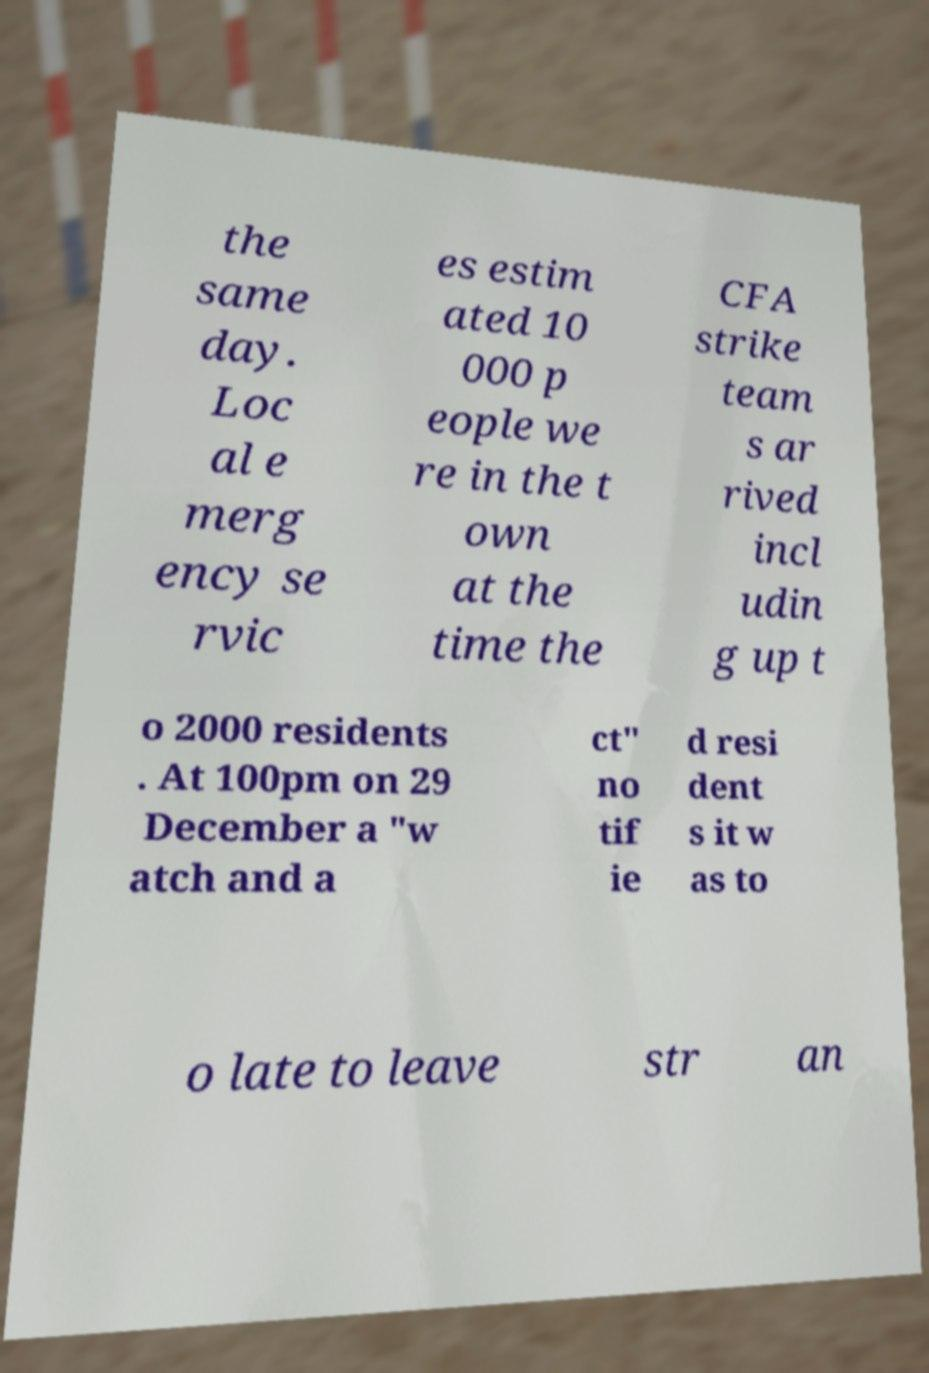Can you read and provide the text displayed in the image?This photo seems to have some interesting text. Can you extract and type it out for me? the same day. Loc al e merg ency se rvic es estim ated 10 000 p eople we re in the t own at the time the CFA strike team s ar rived incl udin g up t o 2000 residents . At 100pm on 29 December a "w atch and a ct" no tif ie d resi dent s it w as to o late to leave str an 